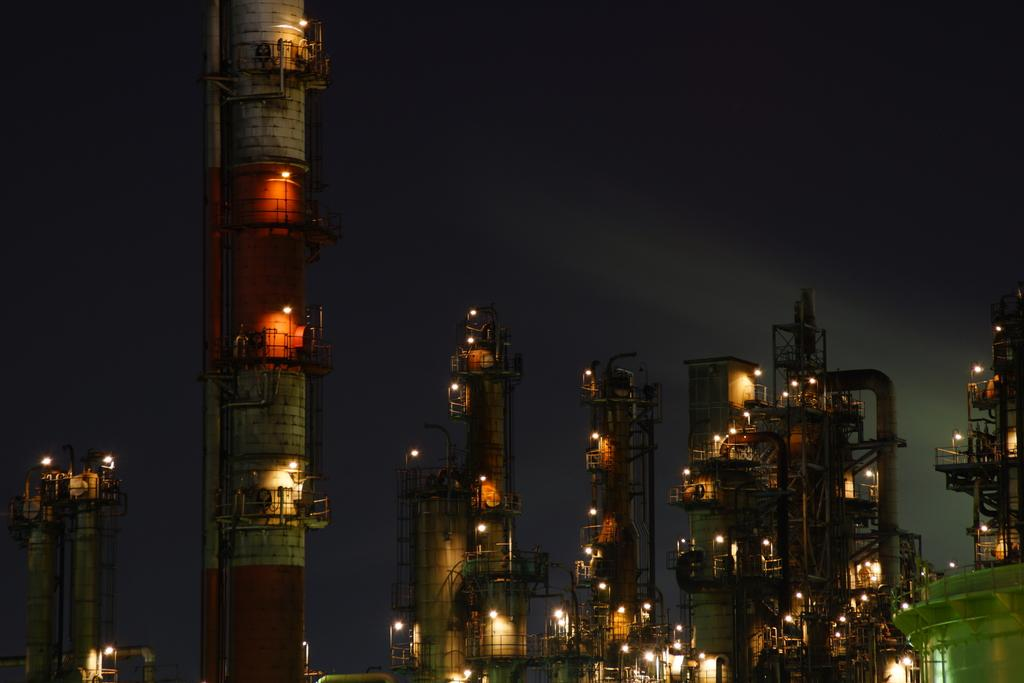What type of structures can be seen in the image? There are many buildings and towers in the image. What feature is visible in the buildings? Lights are visible in the buildings. What color is the background of the image? The background of the image appears black in color. What might be the reason for the black background? The image was likely taken in the dark. Can you tell me how many bears are visible in the image? There are no bears present in the image; it features buildings and towers. What type of zipper can be seen on the daughter's jacket in the image? There is no daughter or jacket present in the image, as it focuses on buildings and towers. 